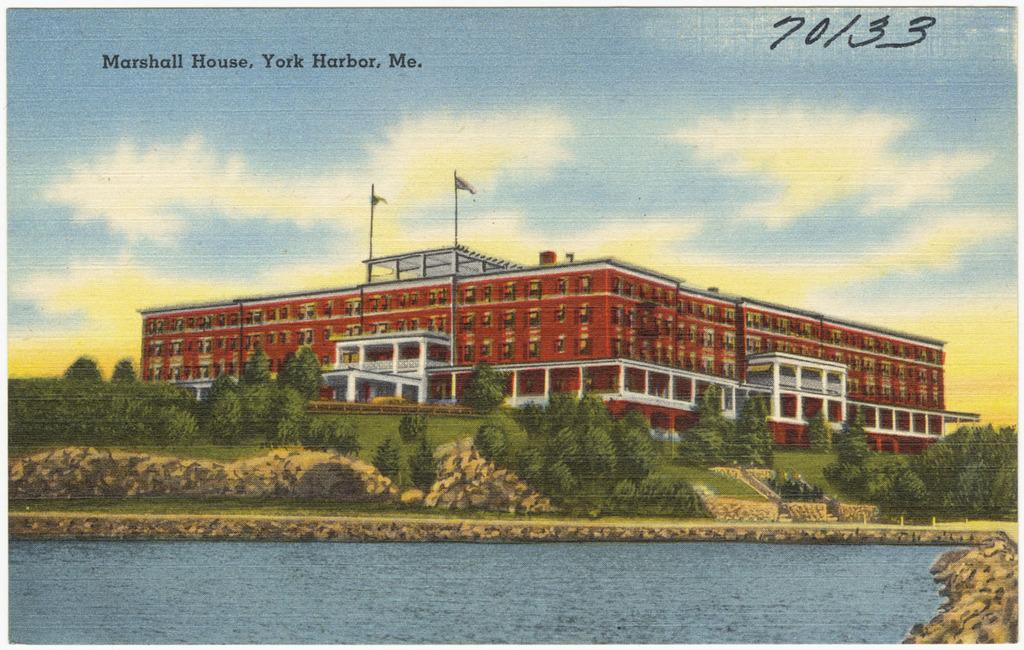<image>
Render a clear and concise summary of the photo. Postcard with a building that says "Marshall House" near the top. 